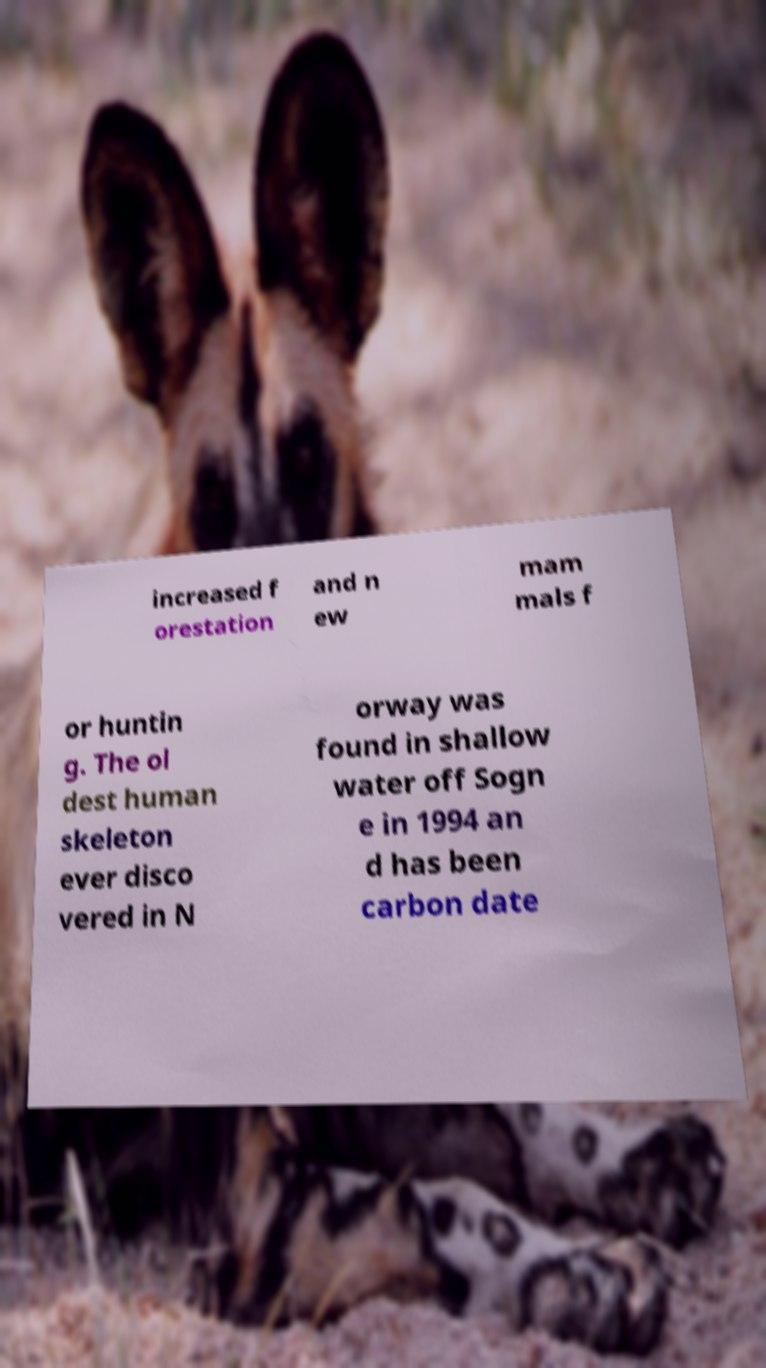I need the written content from this picture converted into text. Can you do that? increased f orestation and n ew mam mals f or huntin g. The ol dest human skeleton ever disco vered in N orway was found in shallow water off Sogn e in 1994 an d has been carbon date 